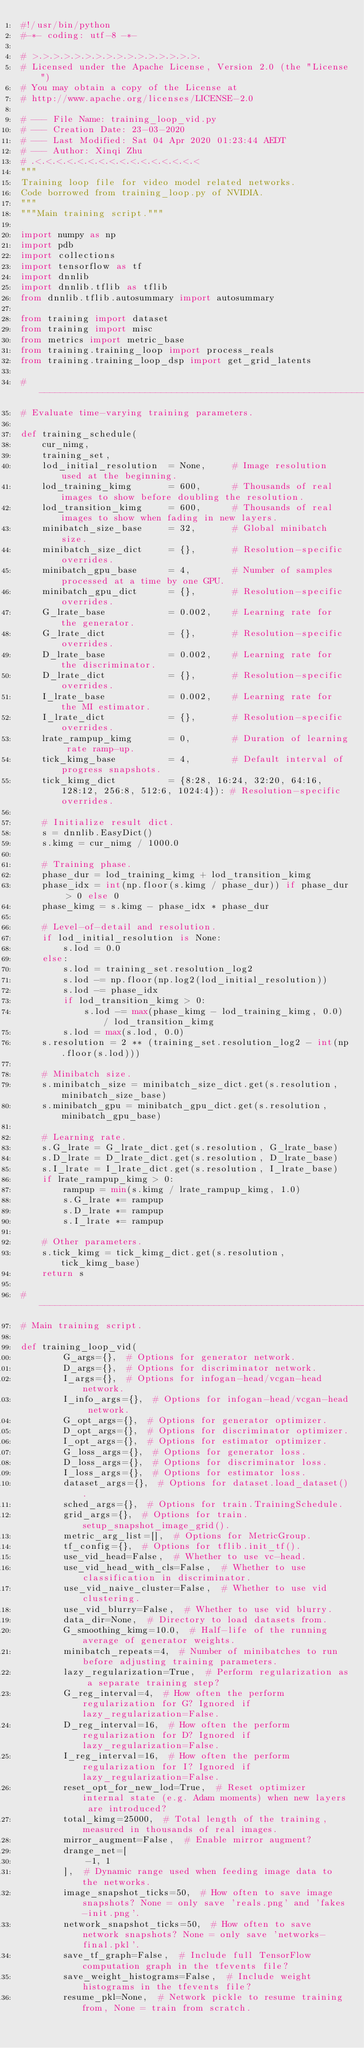Convert code to text. <code><loc_0><loc_0><loc_500><loc_500><_Python_>#!/usr/bin/python
#-*- coding: utf-8 -*-

# >.>.>.>.>.>.>.>.>.>.>.>.>.>.>.>.
# Licensed under the Apache License, Version 2.0 (the "License")
# You may obtain a copy of the License at
# http://www.apache.org/licenses/LICENSE-2.0

# --- File Name: training_loop_vid.py
# --- Creation Date: 23-03-2020
# --- Last Modified: Sat 04 Apr 2020 01:23:44 AEDT
# --- Author: Xinqi Zhu
# .<.<.<.<.<.<.<.<.<.<.<.<.<.<.<.<
"""
Training loop file for video model related networks.
Code borrowed from training_loop.py of NVIDIA.
"""
"""Main training script."""

import numpy as np
import pdb
import collections
import tensorflow as tf
import dnnlib
import dnnlib.tflib as tflib
from dnnlib.tflib.autosummary import autosummary

from training import dataset
from training import misc
from metrics import metric_base
from training.training_loop import process_reals
from training.training_loop_dsp import get_grid_latents

#----------------------------------------------------------------------------
# Evaluate time-varying training parameters.

def training_schedule(
    cur_nimg,
    training_set,
    lod_initial_resolution  = None,     # Image resolution used at the beginning.
    lod_training_kimg       = 600,      # Thousands of real images to show before doubling the resolution.
    lod_transition_kimg     = 600,      # Thousands of real images to show when fading in new layers.
    minibatch_size_base     = 32,       # Global minibatch size.
    minibatch_size_dict     = {},       # Resolution-specific overrides.
    minibatch_gpu_base      = 4,        # Number of samples processed at a time by one GPU.
    minibatch_gpu_dict      = {},       # Resolution-specific overrides.
    G_lrate_base            = 0.002,    # Learning rate for the generator.
    G_lrate_dict            = {},       # Resolution-specific overrides.
    D_lrate_base            = 0.002,    # Learning rate for the discriminator.
    D_lrate_dict            = {},       # Resolution-specific overrides.
    I_lrate_base            = 0.002,    # Learning rate for the MI estimator.
    I_lrate_dict            = {},       # Resolution-specific overrides.
    lrate_rampup_kimg       = 0,        # Duration of learning rate ramp-up.
    tick_kimg_base          = 4,        # Default interval of progress snapshots.
    tick_kimg_dict          = {8:28, 16:24, 32:20, 64:16, 128:12, 256:8, 512:6, 1024:4}): # Resolution-specific overrides.

    # Initialize result dict.
    s = dnnlib.EasyDict()
    s.kimg = cur_nimg / 1000.0

    # Training phase.
    phase_dur = lod_training_kimg + lod_transition_kimg
    phase_idx = int(np.floor(s.kimg / phase_dur)) if phase_dur > 0 else 0
    phase_kimg = s.kimg - phase_idx * phase_dur

    # Level-of-detail and resolution.
    if lod_initial_resolution is None:
        s.lod = 0.0
    else:
        s.lod = training_set.resolution_log2
        s.lod -= np.floor(np.log2(lod_initial_resolution))
        s.lod -= phase_idx
        if lod_transition_kimg > 0:
            s.lod -= max(phase_kimg - lod_training_kimg, 0.0) / lod_transition_kimg
        s.lod = max(s.lod, 0.0)
    s.resolution = 2 ** (training_set.resolution_log2 - int(np.floor(s.lod)))

    # Minibatch size.
    s.minibatch_size = minibatch_size_dict.get(s.resolution, minibatch_size_base)
    s.minibatch_gpu = minibatch_gpu_dict.get(s.resolution, minibatch_gpu_base)

    # Learning rate.
    s.G_lrate = G_lrate_dict.get(s.resolution, G_lrate_base)
    s.D_lrate = D_lrate_dict.get(s.resolution, D_lrate_base)
    s.I_lrate = I_lrate_dict.get(s.resolution, I_lrate_base)
    if lrate_rampup_kimg > 0:
        rampup = min(s.kimg / lrate_rampup_kimg, 1.0)
        s.G_lrate *= rampup
        s.D_lrate *= rampup
        s.I_lrate *= rampup

    # Other parameters.
    s.tick_kimg = tick_kimg_dict.get(s.resolution, tick_kimg_base)
    return s

#----------------------------------------------------------------------------
# Main training script.

def training_loop_vid(
        G_args={},  # Options for generator network.
        D_args={},  # Options for discriminator network.
        I_args={},  # Options for infogan-head/vcgan-head network.
        I_info_args={},  # Options for infogan-head/vcgan-head network.
        G_opt_args={},  # Options for generator optimizer.
        D_opt_args={},  # Options for discriminator optimizer.
        I_opt_args={},  # Options for estimator optimizer.
        G_loss_args={},  # Options for generator loss.
        D_loss_args={},  # Options for discriminator loss.
        I_loss_args={},  # Options for estimator loss.
        dataset_args={},  # Options for dataset.load_dataset().
        sched_args={},  # Options for train.TrainingSchedule.
        grid_args={},  # Options for train.setup_snapshot_image_grid().
        metric_arg_list=[],  # Options for MetricGroup.
        tf_config={},  # Options for tflib.init_tf().
        use_vid_head=False,  # Whether to use vc-head.
        use_vid_head_with_cls=False,  # Whether to use classification in discriminator.
        use_vid_naive_cluster=False,  # Whether to use vid clustering.
        use_vid_blurry=False,  # Whether to use vid blurry.
        data_dir=None,  # Directory to load datasets from.
        G_smoothing_kimg=10.0,  # Half-life of the running average of generator weights.
        minibatch_repeats=4,  # Number of minibatches to run before adjusting training parameters.
        lazy_regularization=True,  # Perform regularization as a separate training step?
        G_reg_interval=4,  # How often the perform regularization for G? Ignored if lazy_regularization=False.
        D_reg_interval=16,  # How often the perform regularization for D? Ignored if lazy_regularization=False.
        I_reg_interval=16,  # How often the perform regularization for I? Ignored if lazy_regularization=False.
        reset_opt_for_new_lod=True,  # Reset optimizer internal state (e.g. Adam moments) when new layers are introduced?
        total_kimg=25000,  # Total length of the training, measured in thousands of real images.
        mirror_augment=False,  # Enable mirror augment?
        drange_net=[
            -1, 1
        ],  # Dynamic range used when feeding image data to the networks.
        image_snapshot_ticks=50,  # How often to save image snapshots? None = only save 'reals.png' and 'fakes-init.png'.
        network_snapshot_ticks=50,  # How often to save network snapshots? None = only save 'networks-final.pkl'.
        save_tf_graph=False,  # Include full TensorFlow computation graph in the tfevents file?
        save_weight_histograms=False,  # Include weight histograms in the tfevents file?
        resume_pkl=None,  # Network pickle to resume training from, None = train from scratch.</code> 